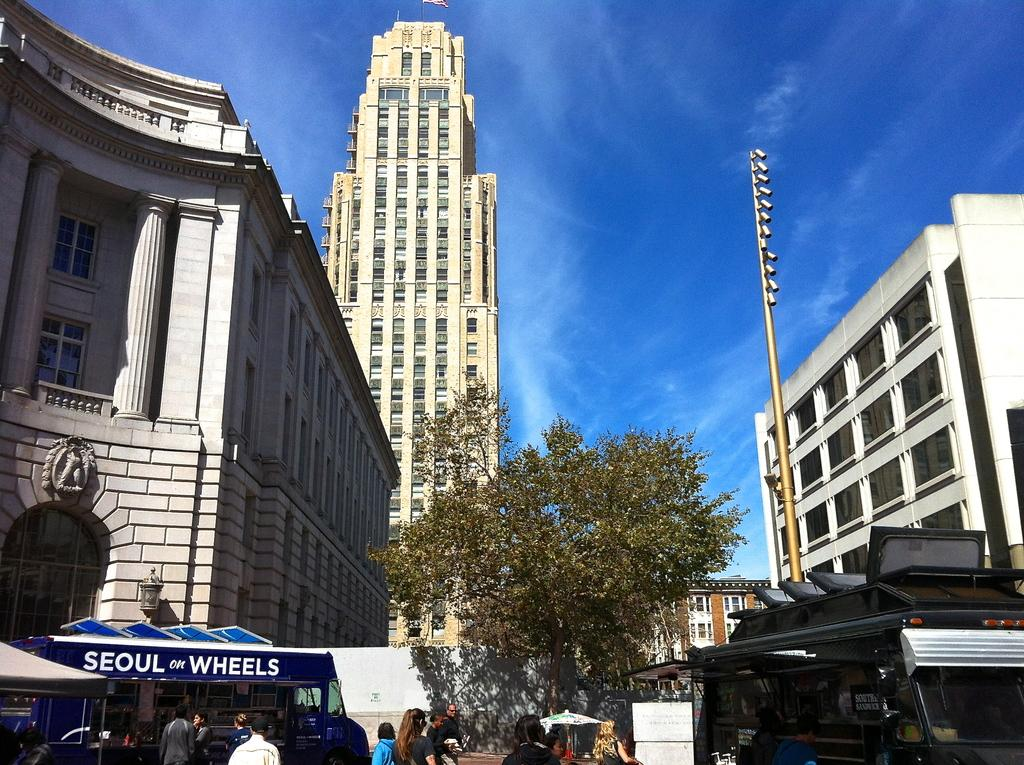What are the people in the image doing? There are persons walking in the image. What else can be seen in the image besides people? There are vehicles and trees visible in the image. What is visible in the background of the image? There are buildings and a clear sky visible in the background of the image. How many bikes are on the shelf in the image? There is no shelf or bikes present in the image. What request is being made by the people in the image? The image does not show any requests being made by the people; they are simply walking. 